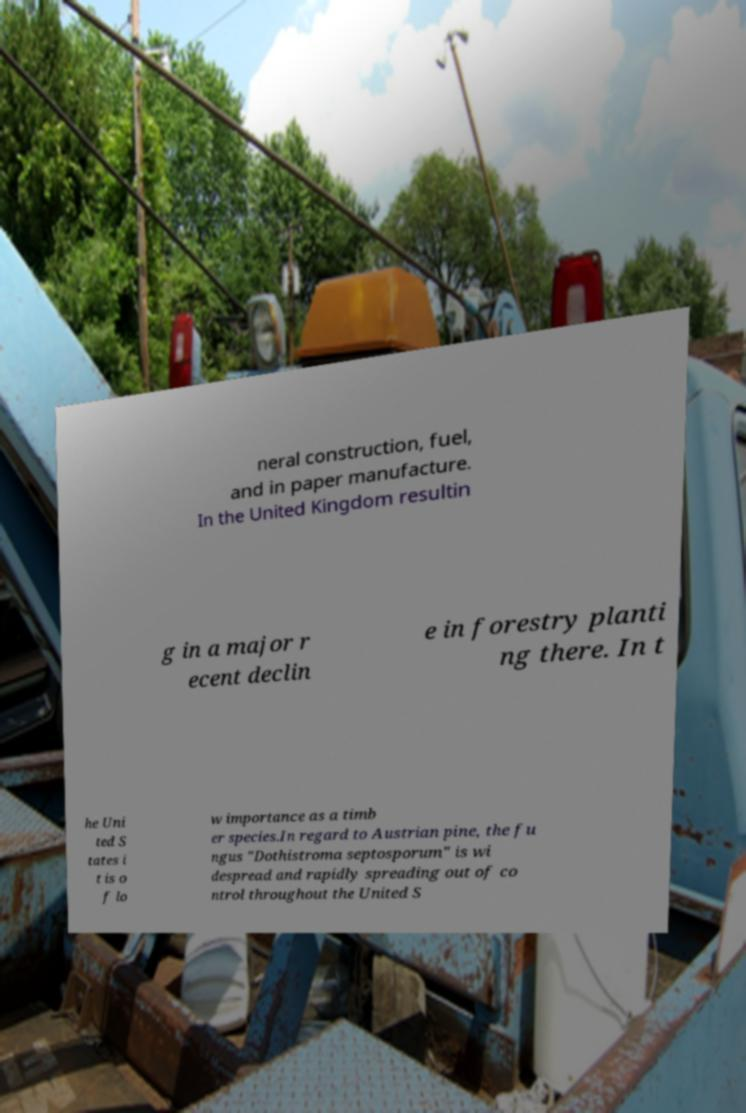Can you read and provide the text displayed in the image?This photo seems to have some interesting text. Can you extract and type it out for me? neral construction, fuel, and in paper manufacture. In the United Kingdom resultin g in a major r ecent declin e in forestry planti ng there. In t he Uni ted S tates i t is o f lo w importance as a timb er species.In regard to Austrian pine, the fu ngus "Dothistroma septosporum" is wi despread and rapidly spreading out of co ntrol throughout the United S 